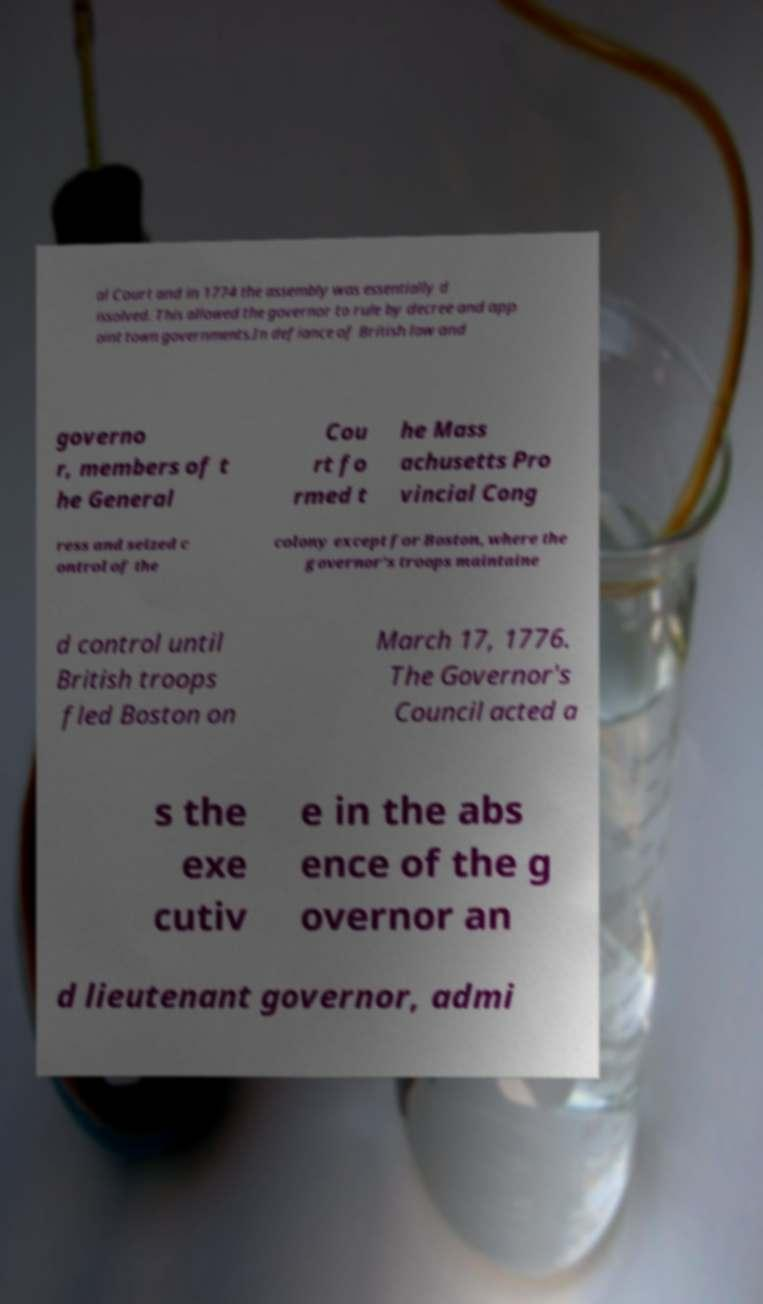For documentation purposes, I need the text within this image transcribed. Could you provide that? al Court and in 1774 the assembly was essentially d issolved. This allowed the governor to rule by decree and app oint town governments.In defiance of British law and governo r, members of t he General Cou rt fo rmed t he Mass achusetts Pro vincial Cong ress and seized c ontrol of the colony except for Boston, where the governor's troops maintaine d control until British troops fled Boston on March 17, 1776. The Governor's Council acted a s the exe cutiv e in the abs ence of the g overnor an d lieutenant governor, admi 